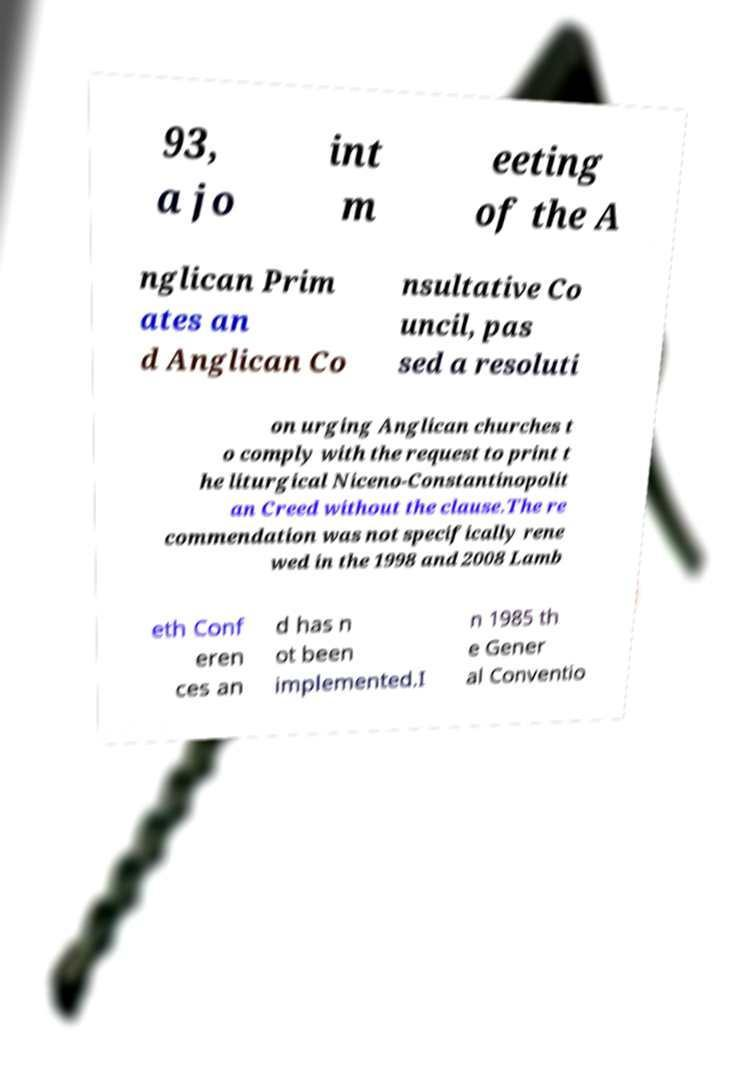Could you extract and type out the text from this image? 93, a jo int m eeting of the A nglican Prim ates an d Anglican Co nsultative Co uncil, pas sed a resoluti on urging Anglican churches t o comply with the request to print t he liturgical Niceno-Constantinopolit an Creed without the clause.The re commendation was not specifically rene wed in the 1998 and 2008 Lamb eth Conf eren ces an d has n ot been implemented.I n 1985 th e Gener al Conventio 